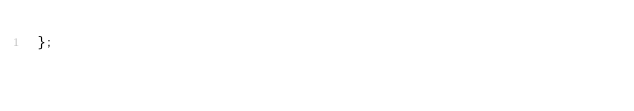Convert code to text. <code><loc_0><loc_0><loc_500><loc_500><_TypeScript_>};
</code> 